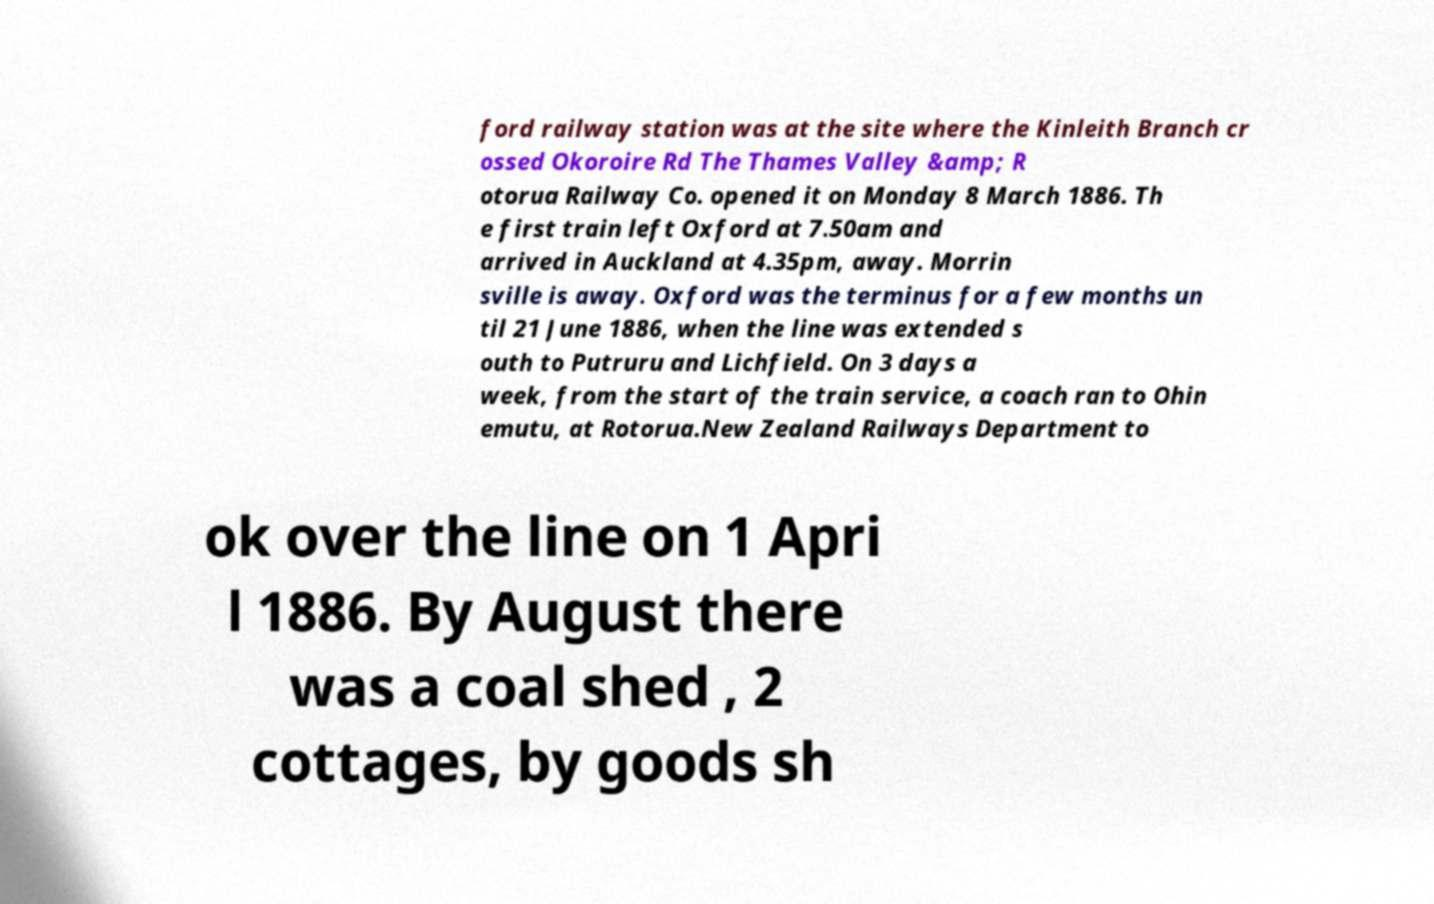Please read and relay the text visible in this image. What does it say? ford railway station was at the site where the Kinleith Branch cr ossed Okoroire Rd The Thames Valley &amp; R otorua Railway Co. opened it on Monday 8 March 1886. Th e first train left Oxford at 7.50am and arrived in Auckland at 4.35pm, away. Morrin sville is away. Oxford was the terminus for a few months un til 21 June 1886, when the line was extended s outh to Putruru and Lichfield. On 3 days a week, from the start of the train service, a coach ran to Ohin emutu, at Rotorua.New Zealand Railways Department to ok over the line on 1 Apri l 1886. By August there was a coal shed , 2 cottages, by goods sh 